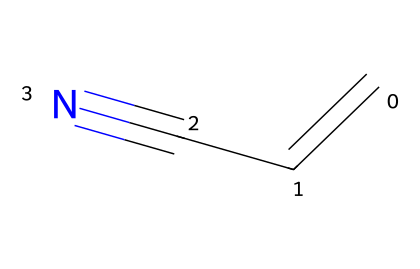How many carbon atoms are in acrylonitrile? The SMILES representation shows "C=CC", indicating there are three carbon atoms in total connected through double and single bonds.
Answer: three What functional group is present in acrylonitrile? The presence of the cyano group "-C#N" at the end of the SMILES indicates that this compound has a nitrile functional group.
Answer: nitrile How many hydrogen atoms are in acrylonitrile? Since each carbon can form up to four bonds, and in the structure provided, two carbons are connected by a double bond and one carbon connects to a nitrogen, the molecule balances to have three hydrogen atoms total.
Answer: three What type of bond connects the carbon atoms in acrylonitrile? The initial part "C=C" indicates a double bond between the first two carbon atoms, while the last carbon is connected through a single bond.
Answer: double bond What does the carbon-nitrogen triple bond in the nitrile group imply about the reactivity of acrylonitrile? The triple bond between carbon and nitrogen in the nitrile implies significant reactivity due to the high electron density and polarity, making it a good candidate for nucleophilic addition reactions.
Answer: high reactivity What is the hybridization of the carbon atoms in acrylonitrile? The carbon atoms involved in the double bond are sp2 hybridized (the two connected by a double bond), while the terminal carbon attached to nitrogen is sp hybridized, due to the triple bond formation with nitrogen.
Answer: sp and sp2 What is the main use of acrylonitrile in products related to basketball? Acrylonitrile is primarily used in the production of synthetic rubber, which is utilized in the manufacturing of basketball shoes for improved durability and performance.
Answer: synthetic rubber 